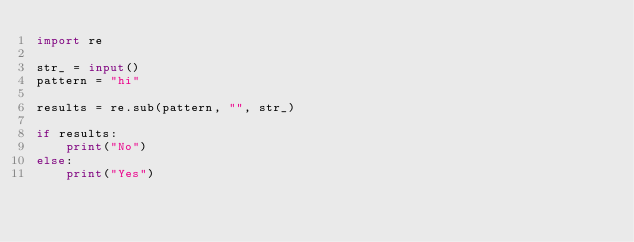Convert code to text. <code><loc_0><loc_0><loc_500><loc_500><_Python_>import re

str_ = input()
pattern = "hi"

results = re.sub(pattern, "", str_)

if results:
    print("No")
else:
    print("Yes")</code> 